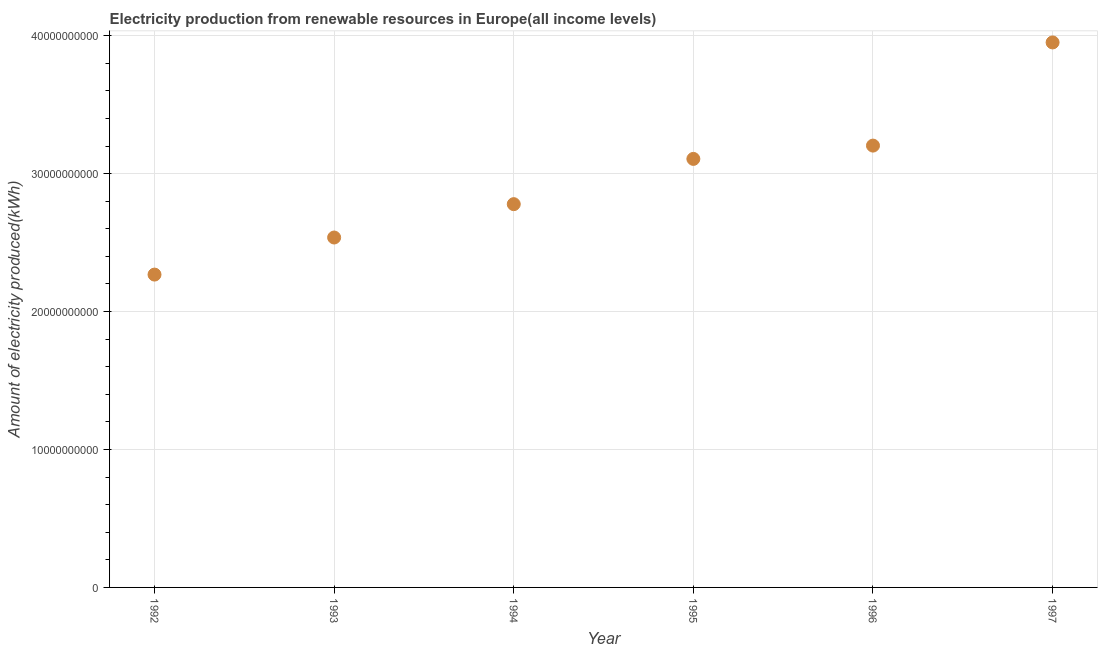What is the amount of electricity produced in 1995?
Provide a succinct answer. 3.11e+1. Across all years, what is the maximum amount of electricity produced?
Your answer should be very brief. 3.95e+1. Across all years, what is the minimum amount of electricity produced?
Provide a succinct answer. 2.27e+1. In which year was the amount of electricity produced maximum?
Your response must be concise. 1997. In which year was the amount of electricity produced minimum?
Provide a short and direct response. 1992. What is the sum of the amount of electricity produced?
Your response must be concise. 1.78e+11. What is the difference between the amount of electricity produced in 1993 and 1997?
Provide a succinct answer. -1.41e+1. What is the average amount of electricity produced per year?
Keep it short and to the point. 2.97e+1. What is the median amount of electricity produced?
Provide a succinct answer. 2.94e+1. In how many years, is the amount of electricity produced greater than 20000000000 kWh?
Your answer should be very brief. 6. What is the ratio of the amount of electricity produced in 1995 to that in 1996?
Give a very brief answer. 0.97. What is the difference between the highest and the second highest amount of electricity produced?
Your response must be concise. 7.48e+09. Is the sum of the amount of electricity produced in 1992 and 1996 greater than the maximum amount of electricity produced across all years?
Your response must be concise. Yes. What is the difference between the highest and the lowest amount of electricity produced?
Keep it short and to the point. 1.68e+1. In how many years, is the amount of electricity produced greater than the average amount of electricity produced taken over all years?
Make the answer very short. 3. Does the amount of electricity produced monotonically increase over the years?
Offer a very short reply. Yes. How many dotlines are there?
Your answer should be very brief. 1. Does the graph contain any zero values?
Provide a short and direct response. No. Does the graph contain grids?
Ensure brevity in your answer.  Yes. What is the title of the graph?
Make the answer very short. Electricity production from renewable resources in Europe(all income levels). What is the label or title of the Y-axis?
Keep it short and to the point. Amount of electricity produced(kWh). What is the Amount of electricity produced(kWh) in 1992?
Provide a short and direct response. 2.27e+1. What is the Amount of electricity produced(kWh) in 1993?
Your response must be concise. 2.54e+1. What is the Amount of electricity produced(kWh) in 1994?
Make the answer very short. 2.78e+1. What is the Amount of electricity produced(kWh) in 1995?
Offer a terse response. 3.11e+1. What is the Amount of electricity produced(kWh) in 1996?
Ensure brevity in your answer.  3.20e+1. What is the Amount of electricity produced(kWh) in 1997?
Your answer should be very brief. 3.95e+1. What is the difference between the Amount of electricity produced(kWh) in 1992 and 1993?
Offer a terse response. -2.69e+09. What is the difference between the Amount of electricity produced(kWh) in 1992 and 1994?
Provide a short and direct response. -5.11e+09. What is the difference between the Amount of electricity produced(kWh) in 1992 and 1995?
Provide a succinct answer. -8.39e+09. What is the difference between the Amount of electricity produced(kWh) in 1992 and 1996?
Your answer should be compact. -9.35e+09. What is the difference between the Amount of electricity produced(kWh) in 1992 and 1997?
Offer a very short reply. -1.68e+1. What is the difference between the Amount of electricity produced(kWh) in 1993 and 1994?
Provide a succinct answer. -2.42e+09. What is the difference between the Amount of electricity produced(kWh) in 1993 and 1995?
Give a very brief answer. -5.70e+09. What is the difference between the Amount of electricity produced(kWh) in 1993 and 1996?
Provide a succinct answer. -6.66e+09. What is the difference between the Amount of electricity produced(kWh) in 1993 and 1997?
Provide a short and direct response. -1.41e+1. What is the difference between the Amount of electricity produced(kWh) in 1994 and 1995?
Offer a very short reply. -3.28e+09. What is the difference between the Amount of electricity produced(kWh) in 1994 and 1996?
Offer a very short reply. -4.24e+09. What is the difference between the Amount of electricity produced(kWh) in 1994 and 1997?
Provide a succinct answer. -1.17e+1. What is the difference between the Amount of electricity produced(kWh) in 1995 and 1996?
Provide a short and direct response. -9.64e+08. What is the difference between the Amount of electricity produced(kWh) in 1995 and 1997?
Provide a succinct answer. -8.44e+09. What is the difference between the Amount of electricity produced(kWh) in 1996 and 1997?
Provide a short and direct response. -7.48e+09. What is the ratio of the Amount of electricity produced(kWh) in 1992 to that in 1993?
Keep it short and to the point. 0.89. What is the ratio of the Amount of electricity produced(kWh) in 1992 to that in 1994?
Make the answer very short. 0.82. What is the ratio of the Amount of electricity produced(kWh) in 1992 to that in 1995?
Give a very brief answer. 0.73. What is the ratio of the Amount of electricity produced(kWh) in 1992 to that in 1996?
Provide a short and direct response. 0.71. What is the ratio of the Amount of electricity produced(kWh) in 1992 to that in 1997?
Offer a terse response. 0.57. What is the ratio of the Amount of electricity produced(kWh) in 1993 to that in 1995?
Ensure brevity in your answer.  0.82. What is the ratio of the Amount of electricity produced(kWh) in 1993 to that in 1996?
Provide a succinct answer. 0.79. What is the ratio of the Amount of electricity produced(kWh) in 1993 to that in 1997?
Your answer should be very brief. 0.64. What is the ratio of the Amount of electricity produced(kWh) in 1994 to that in 1995?
Ensure brevity in your answer.  0.89. What is the ratio of the Amount of electricity produced(kWh) in 1994 to that in 1996?
Keep it short and to the point. 0.87. What is the ratio of the Amount of electricity produced(kWh) in 1994 to that in 1997?
Keep it short and to the point. 0.7. What is the ratio of the Amount of electricity produced(kWh) in 1995 to that in 1997?
Your response must be concise. 0.79. What is the ratio of the Amount of electricity produced(kWh) in 1996 to that in 1997?
Your response must be concise. 0.81. 